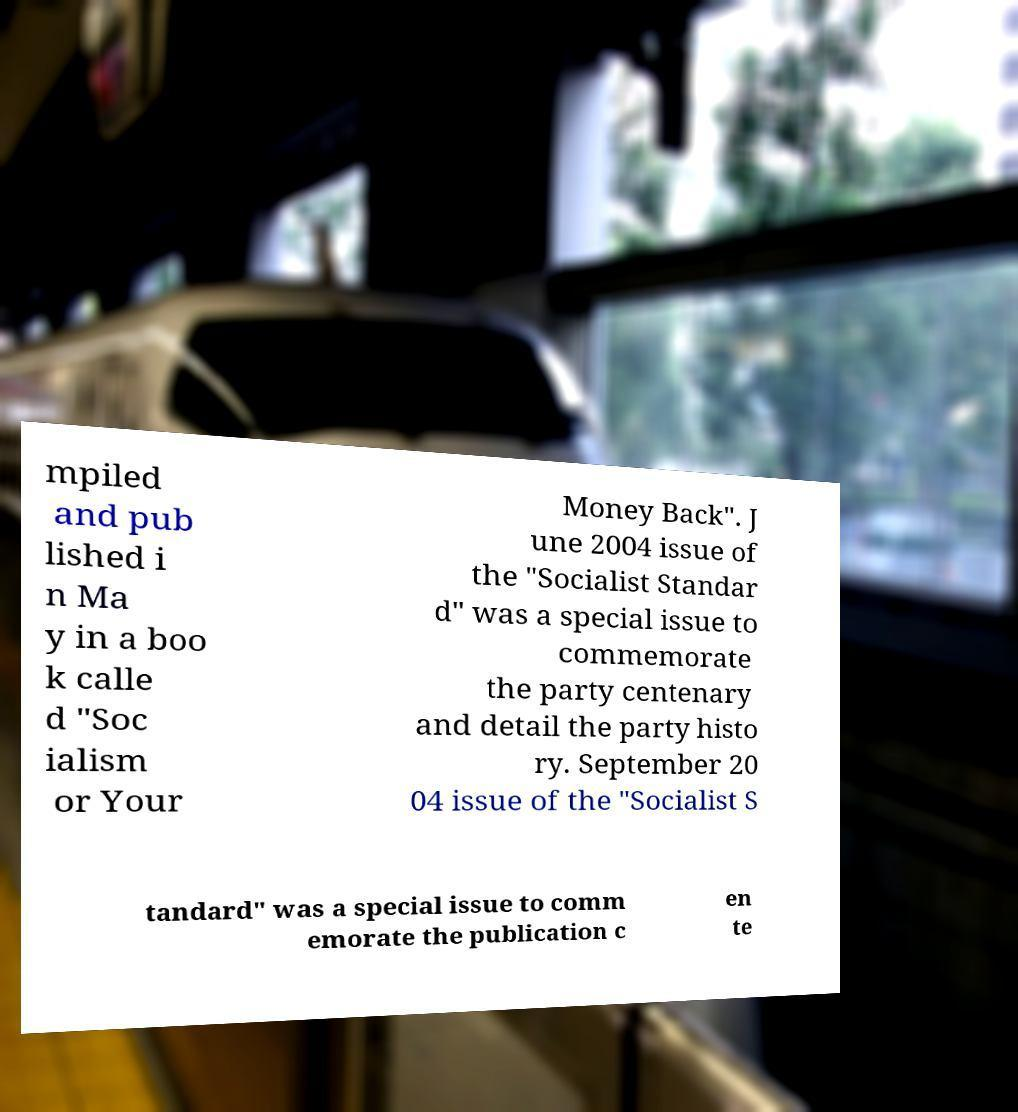Please read and relay the text visible in this image. What does it say? mpiled and pub lished i n Ma y in a boo k calle d "Soc ialism or Your Money Back". J une 2004 issue of the "Socialist Standar d" was a special issue to commemorate the party centenary and detail the party histo ry. September 20 04 issue of the "Socialist S tandard" was a special issue to comm emorate the publication c en te 